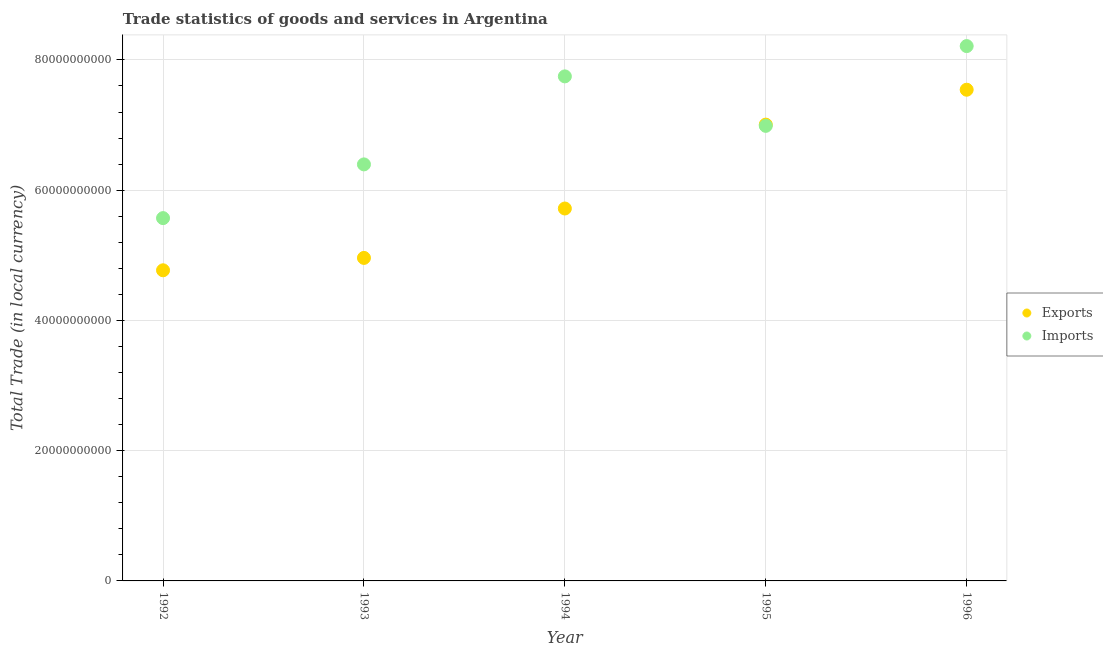Is the number of dotlines equal to the number of legend labels?
Provide a succinct answer. Yes. What is the imports of goods and services in 1992?
Your answer should be very brief. 5.57e+1. Across all years, what is the maximum imports of goods and services?
Offer a very short reply. 8.21e+1. Across all years, what is the minimum imports of goods and services?
Give a very brief answer. 5.57e+1. In which year was the imports of goods and services minimum?
Provide a succinct answer. 1992. What is the total imports of goods and services in the graph?
Your answer should be compact. 3.49e+11. What is the difference between the export of goods and services in 1993 and that in 1995?
Make the answer very short. -2.05e+1. What is the difference between the export of goods and services in 1996 and the imports of goods and services in 1992?
Offer a terse response. 1.97e+1. What is the average imports of goods and services per year?
Provide a succinct answer. 6.98e+1. In the year 1996, what is the difference between the imports of goods and services and export of goods and services?
Your response must be concise. 6.70e+09. What is the ratio of the imports of goods and services in 1995 to that in 1996?
Offer a very short reply. 0.85. What is the difference between the highest and the second highest imports of goods and services?
Provide a succinct answer. 4.65e+09. What is the difference between the highest and the lowest export of goods and services?
Offer a very short reply. 2.77e+1. In how many years, is the imports of goods and services greater than the average imports of goods and services taken over all years?
Make the answer very short. 3. Does the imports of goods and services monotonically increase over the years?
Keep it short and to the point. No. Is the imports of goods and services strictly less than the export of goods and services over the years?
Ensure brevity in your answer.  No. How many dotlines are there?
Give a very brief answer. 2. What is the difference between two consecutive major ticks on the Y-axis?
Your answer should be very brief. 2.00e+1. Where does the legend appear in the graph?
Your answer should be very brief. Center right. How many legend labels are there?
Your answer should be compact. 2. What is the title of the graph?
Ensure brevity in your answer.  Trade statistics of goods and services in Argentina. What is the label or title of the X-axis?
Keep it short and to the point. Year. What is the label or title of the Y-axis?
Offer a terse response. Total Trade (in local currency). What is the Total Trade (in local currency) in Exports in 1992?
Make the answer very short. 4.77e+1. What is the Total Trade (in local currency) in Imports in 1992?
Your answer should be compact. 5.57e+1. What is the Total Trade (in local currency) of Exports in 1993?
Provide a short and direct response. 4.96e+1. What is the Total Trade (in local currency) in Imports in 1993?
Provide a succinct answer. 6.40e+1. What is the Total Trade (in local currency) of Exports in 1994?
Offer a very short reply. 5.72e+1. What is the Total Trade (in local currency) of Imports in 1994?
Your response must be concise. 7.75e+1. What is the Total Trade (in local currency) in Exports in 1995?
Your answer should be very brief. 7.01e+1. What is the Total Trade (in local currency) of Imports in 1995?
Offer a very short reply. 6.99e+1. What is the Total Trade (in local currency) of Exports in 1996?
Keep it short and to the point. 7.54e+1. What is the Total Trade (in local currency) of Imports in 1996?
Give a very brief answer. 8.21e+1. Across all years, what is the maximum Total Trade (in local currency) of Exports?
Ensure brevity in your answer.  7.54e+1. Across all years, what is the maximum Total Trade (in local currency) of Imports?
Your answer should be compact. 8.21e+1. Across all years, what is the minimum Total Trade (in local currency) in Exports?
Give a very brief answer. 4.77e+1. Across all years, what is the minimum Total Trade (in local currency) in Imports?
Give a very brief answer. 5.57e+1. What is the total Total Trade (in local currency) in Exports in the graph?
Your response must be concise. 3.00e+11. What is the total Total Trade (in local currency) in Imports in the graph?
Keep it short and to the point. 3.49e+11. What is the difference between the Total Trade (in local currency) in Exports in 1992 and that in 1993?
Provide a short and direct response. -1.90e+09. What is the difference between the Total Trade (in local currency) in Imports in 1992 and that in 1993?
Your answer should be very brief. -8.25e+09. What is the difference between the Total Trade (in local currency) of Exports in 1992 and that in 1994?
Provide a short and direct response. -9.49e+09. What is the difference between the Total Trade (in local currency) in Imports in 1992 and that in 1994?
Provide a short and direct response. -2.18e+1. What is the difference between the Total Trade (in local currency) of Exports in 1992 and that in 1995?
Offer a very short reply. -2.24e+1. What is the difference between the Total Trade (in local currency) in Imports in 1992 and that in 1995?
Keep it short and to the point. -1.42e+1. What is the difference between the Total Trade (in local currency) of Exports in 1992 and that in 1996?
Your response must be concise. -2.77e+1. What is the difference between the Total Trade (in local currency) of Imports in 1992 and that in 1996?
Ensure brevity in your answer.  -2.64e+1. What is the difference between the Total Trade (in local currency) of Exports in 1993 and that in 1994?
Offer a very short reply. -7.59e+09. What is the difference between the Total Trade (in local currency) in Imports in 1993 and that in 1994?
Your answer should be very brief. -1.35e+1. What is the difference between the Total Trade (in local currency) of Exports in 1993 and that in 1995?
Your answer should be compact. -2.05e+1. What is the difference between the Total Trade (in local currency) of Imports in 1993 and that in 1995?
Offer a terse response. -5.92e+09. What is the difference between the Total Trade (in local currency) in Exports in 1993 and that in 1996?
Provide a short and direct response. -2.58e+1. What is the difference between the Total Trade (in local currency) in Imports in 1993 and that in 1996?
Provide a short and direct response. -1.82e+1. What is the difference between the Total Trade (in local currency) in Exports in 1994 and that in 1995?
Make the answer very short. -1.29e+1. What is the difference between the Total Trade (in local currency) of Imports in 1994 and that in 1995?
Your response must be concise. 7.60e+09. What is the difference between the Total Trade (in local currency) of Exports in 1994 and that in 1996?
Offer a terse response. -1.82e+1. What is the difference between the Total Trade (in local currency) of Imports in 1994 and that in 1996?
Provide a short and direct response. -4.65e+09. What is the difference between the Total Trade (in local currency) in Exports in 1995 and that in 1996?
Offer a very short reply. -5.36e+09. What is the difference between the Total Trade (in local currency) of Imports in 1995 and that in 1996?
Offer a terse response. -1.22e+1. What is the difference between the Total Trade (in local currency) of Exports in 1992 and the Total Trade (in local currency) of Imports in 1993?
Offer a terse response. -1.63e+1. What is the difference between the Total Trade (in local currency) of Exports in 1992 and the Total Trade (in local currency) of Imports in 1994?
Offer a terse response. -2.98e+1. What is the difference between the Total Trade (in local currency) of Exports in 1992 and the Total Trade (in local currency) of Imports in 1995?
Offer a very short reply. -2.22e+1. What is the difference between the Total Trade (in local currency) of Exports in 1992 and the Total Trade (in local currency) of Imports in 1996?
Your answer should be very brief. -3.44e+1. What is the difference between the Total Trade (in local currency) of Exports in 1993 and the Total Trade (in local currency) of Imports in 1994?
Provide a short and direct response. -2.79e+1. What is the difference between the Total Trade (in local currency) in Exports in 1993 and the Total Trade (in local currency) in Imports in 1995?
Your response must be concise. -2.03e+1. What is the difference between the Total Trade (in local currency) in Exports in 1993 and the Total Trade (in local currency) in Imports in 1996?
Offer a very short reply. -3.25e+1. What is the difference between the Total Trade (in local currency) of Exports in 1994 and the Total Trade (in local currency) of Imports in 1995?
Ensure brevity in your answer.  -1.27e+1. What is the difference between the Total Trade (in local currency) in Exports in 1994 and the Total Trade (in local currency) in Imports in 1996?
Your answer should be very brief. -2.49e+1. What is the difference between the Total Trade (in local currency) of Exports in 1995 and the Total Trade (in local currency) of Imports in 1996?
Offer a terse response. -1.21e+1. What is the average Total Trade (in local currency) in Exports per year?
Give a very brief answer. 6.00e+1. What is the average Total Trade (in local currency) in Imports per year?
Give a very brief answer. 6.98e+1. In the year 1992, what is the difference between the Total Trade (in local currency) of Exports and Total Trade (in local currency) of Imports?
Your answer should be compact. -8.01e+09. In the year 1993, what is the difference between the Total Trade (in local currency) of Exports and Total Trade (in local currency) of Imports?
Give a very brief answer. -1.44e+1. In the year 1994, what is the difference between the Total Trade (in local currency) in Exports and Total Trade (in local currency) in Imports?
Keep it short and to the point. -2.03e+1. In the year 1995, what is the difference between the Total Trade (in local currency) of Exports and Total Trade (in local currency) of Imports?
Provide a short and direct response. 1.91e+08. In the year 1996, what is the difference between the Total Trade (in local currency) in Exports and Total Trade (in local currency) in Imports?
Provide a succinct answer. -6.70e+09. What is the ratio of the Total Trade (in local currency) of Exports in 1992 to that in 1993?
Your answer should be very brief. 0.96. What is the ratio of the Total Trade (in local currency) of Imports in 1992 to that in 1993?
Ensure brevity in your answer.  0.87. What is the ratio of the Total Trade (in local currency) of Exports in 1992 to that in 1994?
Your answer should be compact. 0.83. What is the ratio of the Total Trade (in local currency) of Imports in 1992 to that in 1994?
Give a very brief answer. 0.72. What is the ratio of the Total Trade (in local currency) of Exports in 1992 to that in 1995?
Your answer should be compact. 0.68. What is the ratio of the Total Trade (in local currency) of Imports in 1992 to that in 1995?
Provide a short and direct response. 0.8. What is the ratio of the Total Trade (in local currency) of Exports in 1992 to that in 1996?
Offer a terse response. 0.63. What is the ratio of the Total Trade (in local currency) in Imports in 1992 to that in 1996?
Your answer should be compact. 0.68. What is the ratio of the Total Trade (in local currency) of Exports in 1993 to that in 1994?
Provide a succinct answer. 0.87. What is the ratio of the Total Trade (in local currency) of Imports in 1993 to that in 1994?
Your answer should be compact. 0.83. What is the ratio of the Total Trade (in local currency) of Exports in 1993 to that in 1995?
Make the answer very short. 0.71. What is the ratio of the Total Trade (in local currency) of Imports in 1993 to that in 1995?
Offer a very short reply. 0.92. What is the ratio of the Total Trade (in local currency) of Exports in 1993 to that in 1996?
Provide a succinct answer. 0.66. What is the ratio of the Total Trade (in local currency) in Imports in 1993 to that in 1996?
Provide a succinct answer. 0.78. What is the ratio of the Total Trade (in local currency) in Exports in 1994 to that in 1995?
Provide a succinct answer. 0.82. What is the ratio of the Total Trade (in local currency) of Imports in 1994 to that in 1995?
Keep it short and to the point. 1.11. What is the ratio of the Total Trade (in local currency) in Exports in 1994 to that in 1996?
Give a very brief answer. 0.76. What is the ratio of the Total Trade (in local currency) of Imports in 1994 to that in 1996?
Provide a succinct answer. 0.94. What is the ratio of the Total Trade (in local currency) in Exports in 1995 to that in 1996?
Offer a terse response. 0.93. What is the ratio of the Total Trade (in local currency) in Imports in 1995 to that in 1996?
Your answer should be very brief. 0.85. What is the difference between the highest and the second highest Total Trade (in local currency) in Exports?
Provide a succinct answer. 5.36e+09. What is the difference between the highest and the second highest Total Trade (in local currency) of Imports?
Ensure brevity in your answer.  4.65e+09. What is the difference between the highest and the lowest Total Trade (in local currency) in Exports?
Offer a terse response. 2.77e+1. What is the difference between the highest and the lowest Total Trade (in local currency) in Imports?
Your answer should be compact. 2.64e+1. 